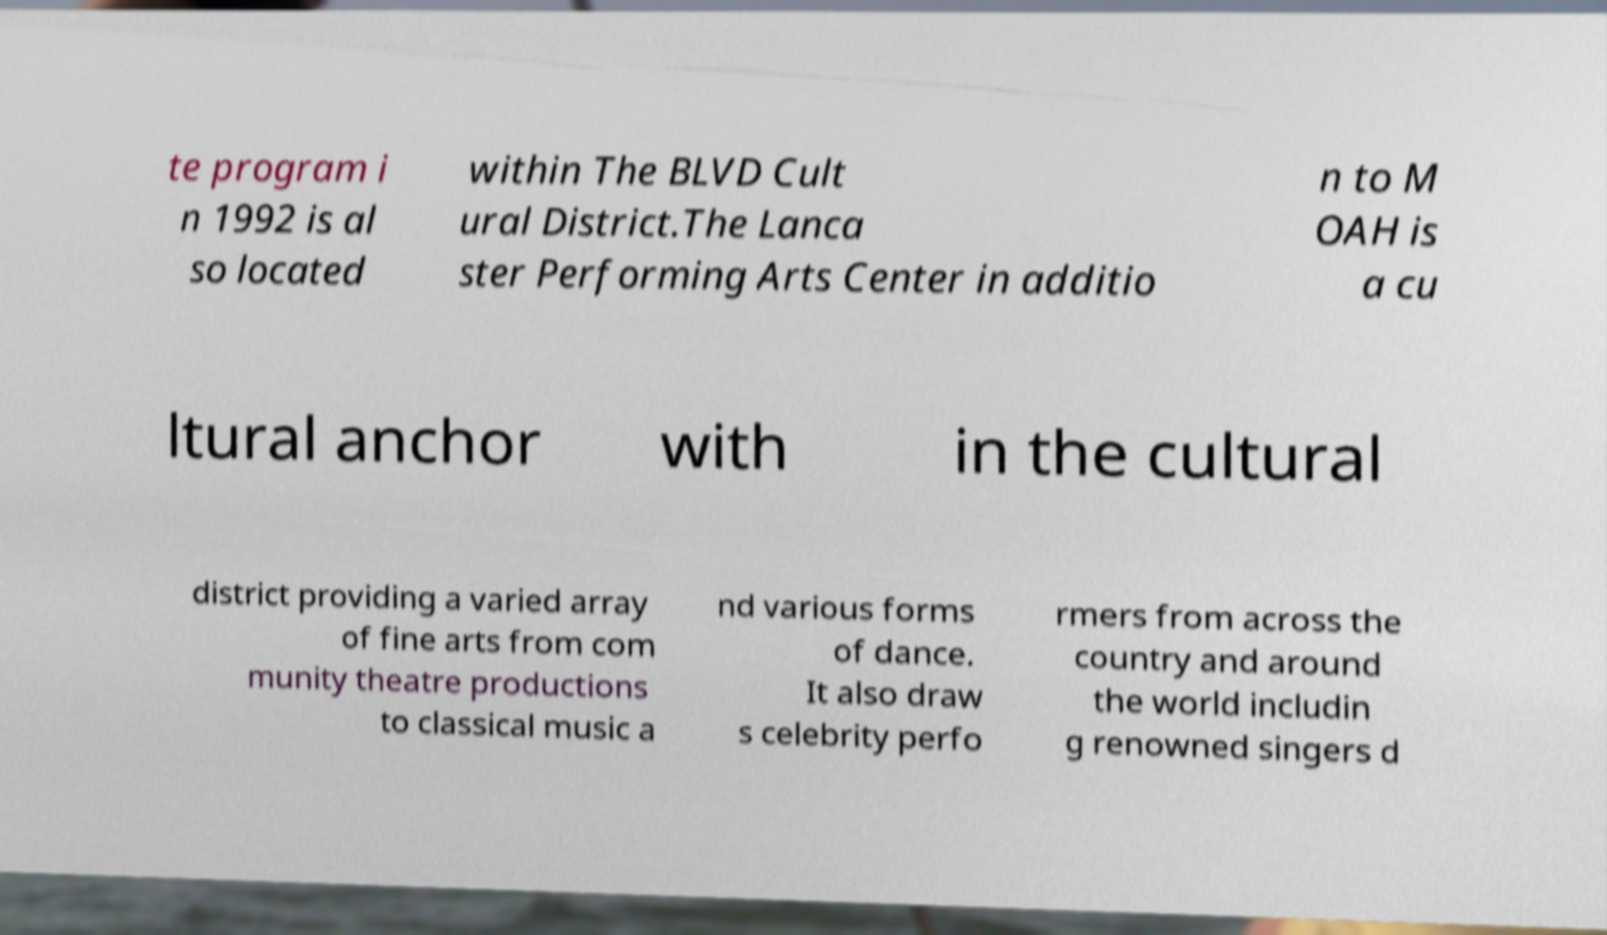Could you assist in decoding the text presented in this image and type it out clearly? te program i n 1992 is al so located within The BLVD Cult ural District.The Lanca ster Performing Arts Center in additio n to M OAH is a cu ltural anchor with in the cultural district providing a varied array of fine arts from com munity theatre productions to classical music a nd various forms of dance. It also draw s celebrity perfo rmers from across the country and around the world includin g renowned singers d 